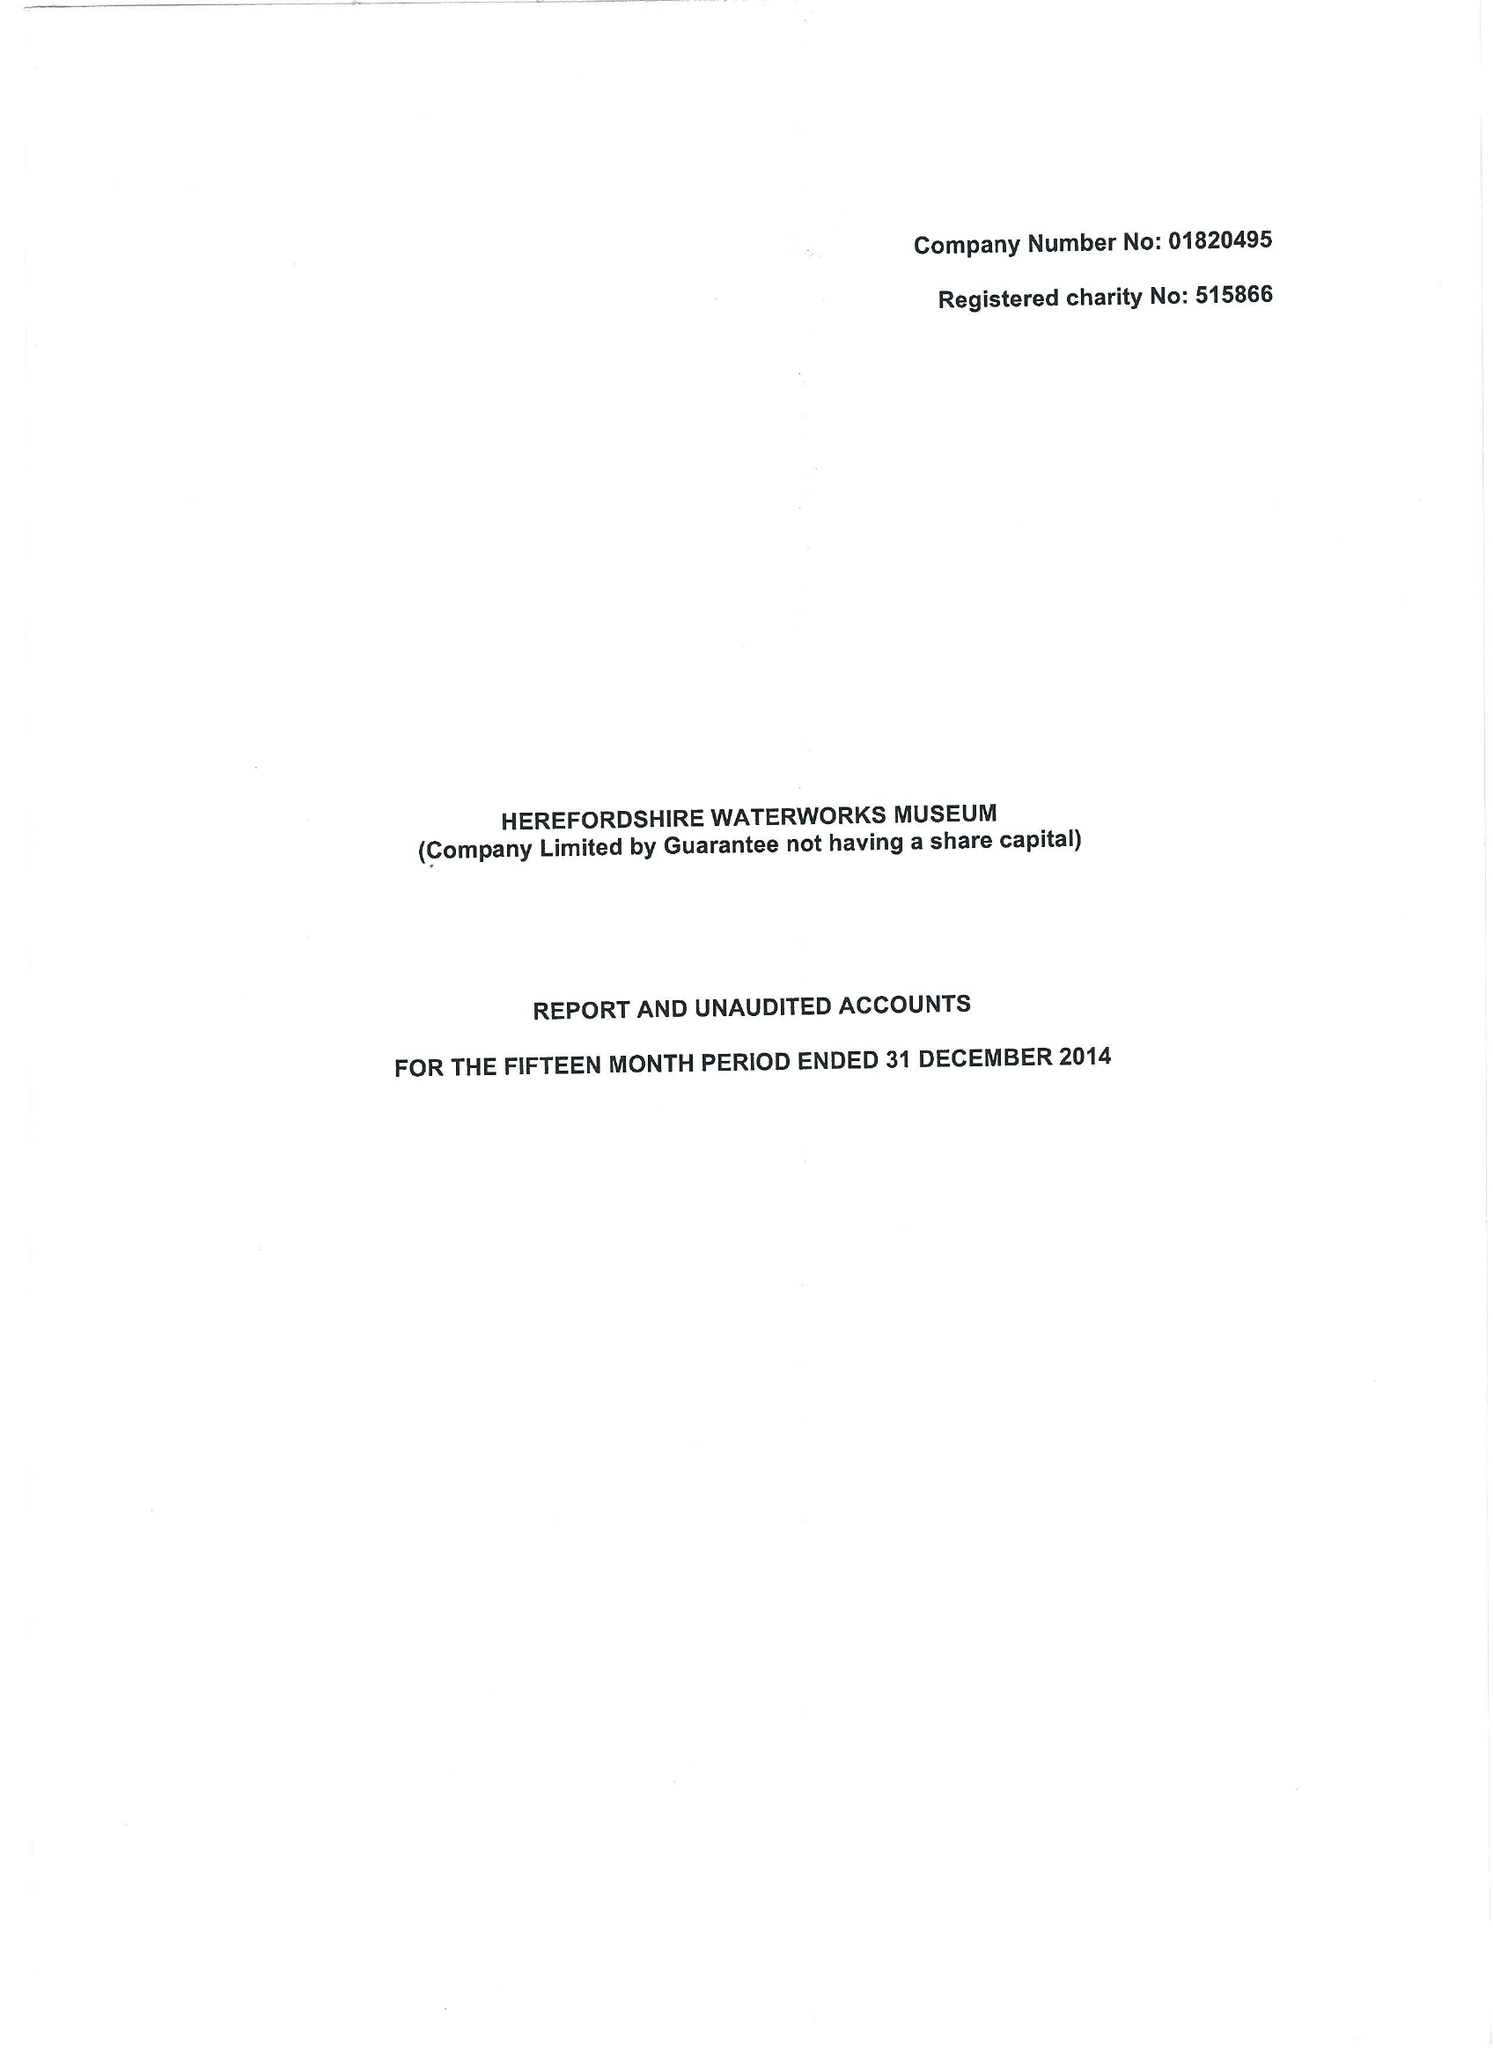What is the value for the address__postcode?
Answer the question using a single word or phrase. HR4 0LJ 